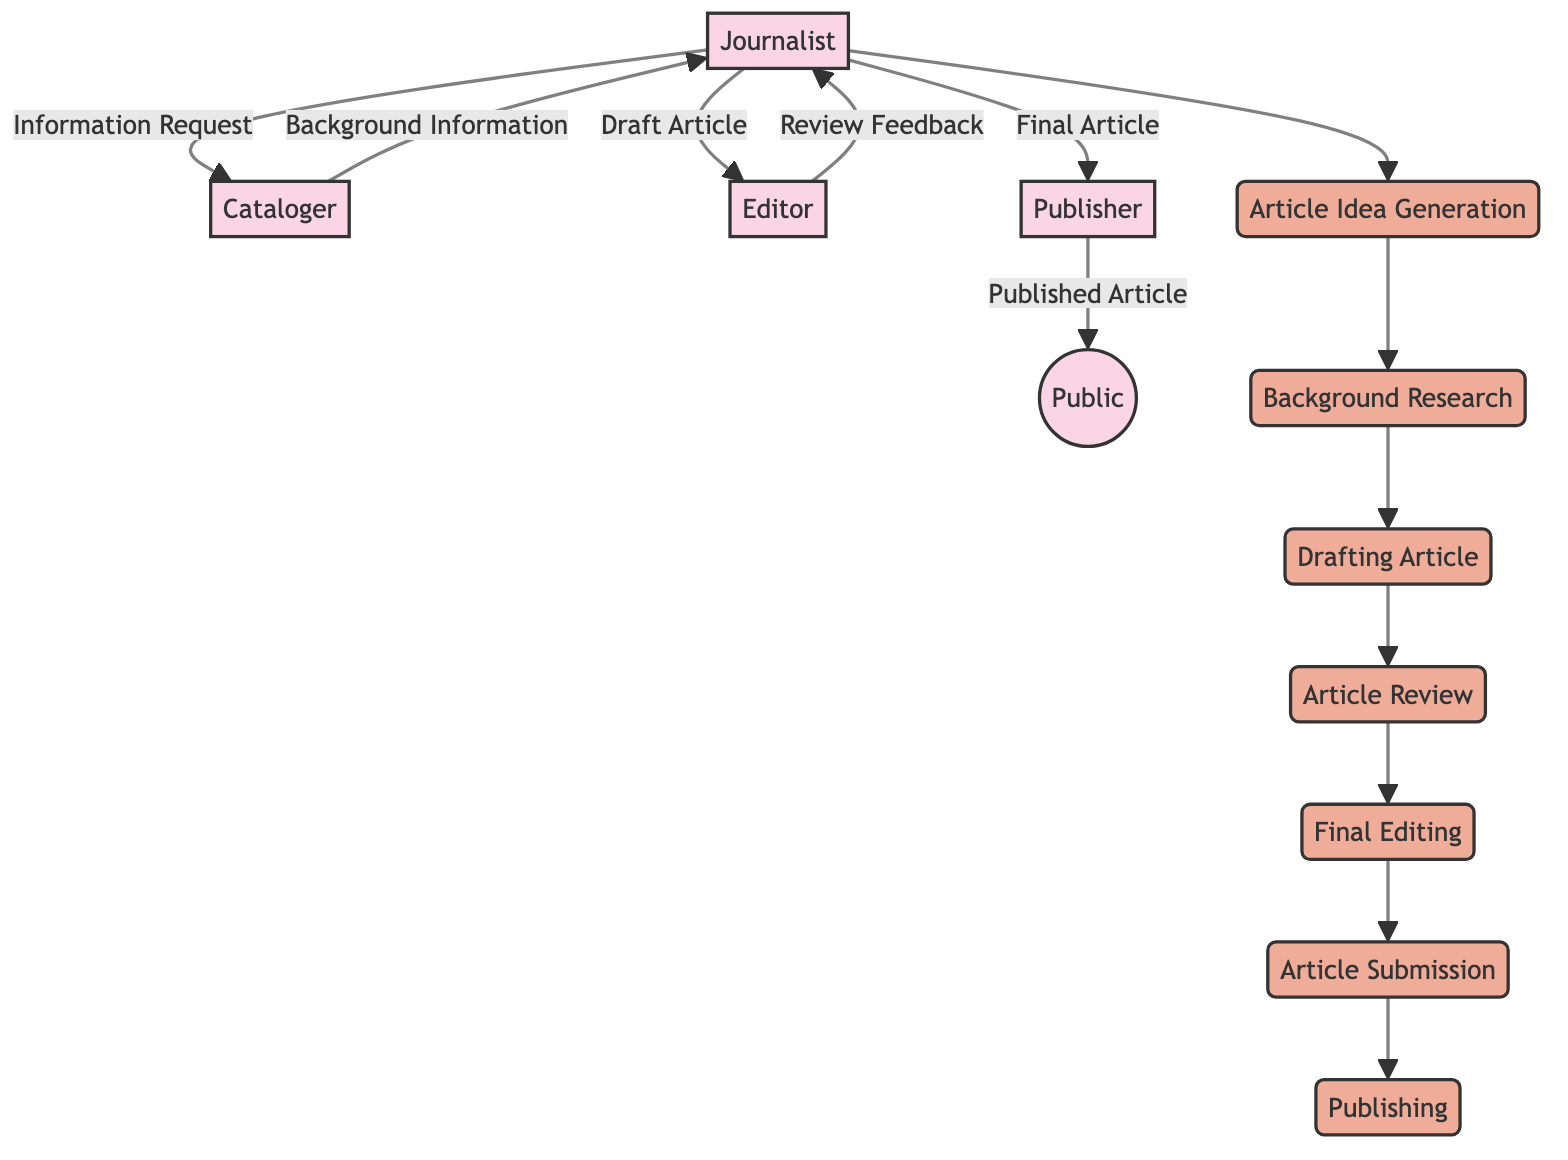What is the first process in the article submission workflow? The first process in the diagram is named "Article Idea Generation". It is the initial step where the journalist begins the creative process of generating ideas for classical music articles.
Answer: Article Idea Generation Who provides the background information to the journalist? The cataloger is responsible for providing background information to the journalist. This is shown by the directed arrow from the cataloger to the journalist labeled "Background Information".
Answer: Cataloger How many entities are involved in the process? The diagram lists four distinct entities: Journalist, Cataloger, Editor, and Publisher. Counting each of these gives a total of four entities involved in the classical music article submission process.
Answer: Four What is the final output of the process? The final output of the process is the "Published Article". This is indicated by the flow going from the Publisher to the Public, where the publisher releases the article to the public.
Answer: Published Article What does the Editor provide to the Journalist? The editor provides "Review Feedback" to the journalist after reviewing the draft of the article. This is illustrated by the arrow from the editor to the journalist labeled "Review Feedback".
Answer: Review Feedback Which process immediately follows "Final Editing"? Immediately following "Final Editing" is the process called "Article Submission". This shows that after final edits are made, the next step is to submit the article to the publisher.
Answer: Article Submission How many total processes are shown in the diagram? The diagram shows seven processes in total: Article Idea Generation, Background Research, Drafting Article, Article Review, Final Editing, Article Submission, and Publishing. Counting each of these processes results in a total of seven.
Answer: Seven Which entity is responsible for publishing the final article? The publisher is responsible for publishing the final article, as depicted by the directed arrow leading from the "Final Article" to the publisher entity, which then connects to the public.
Answer: Publisher What is the role of the Cataloger in the process? The role of the cataloger involves providing accurate references and background information during the "Background Research" phase, aligning with the need for thorough information to guide the journalist's article writing.
Answer: Providing background information 